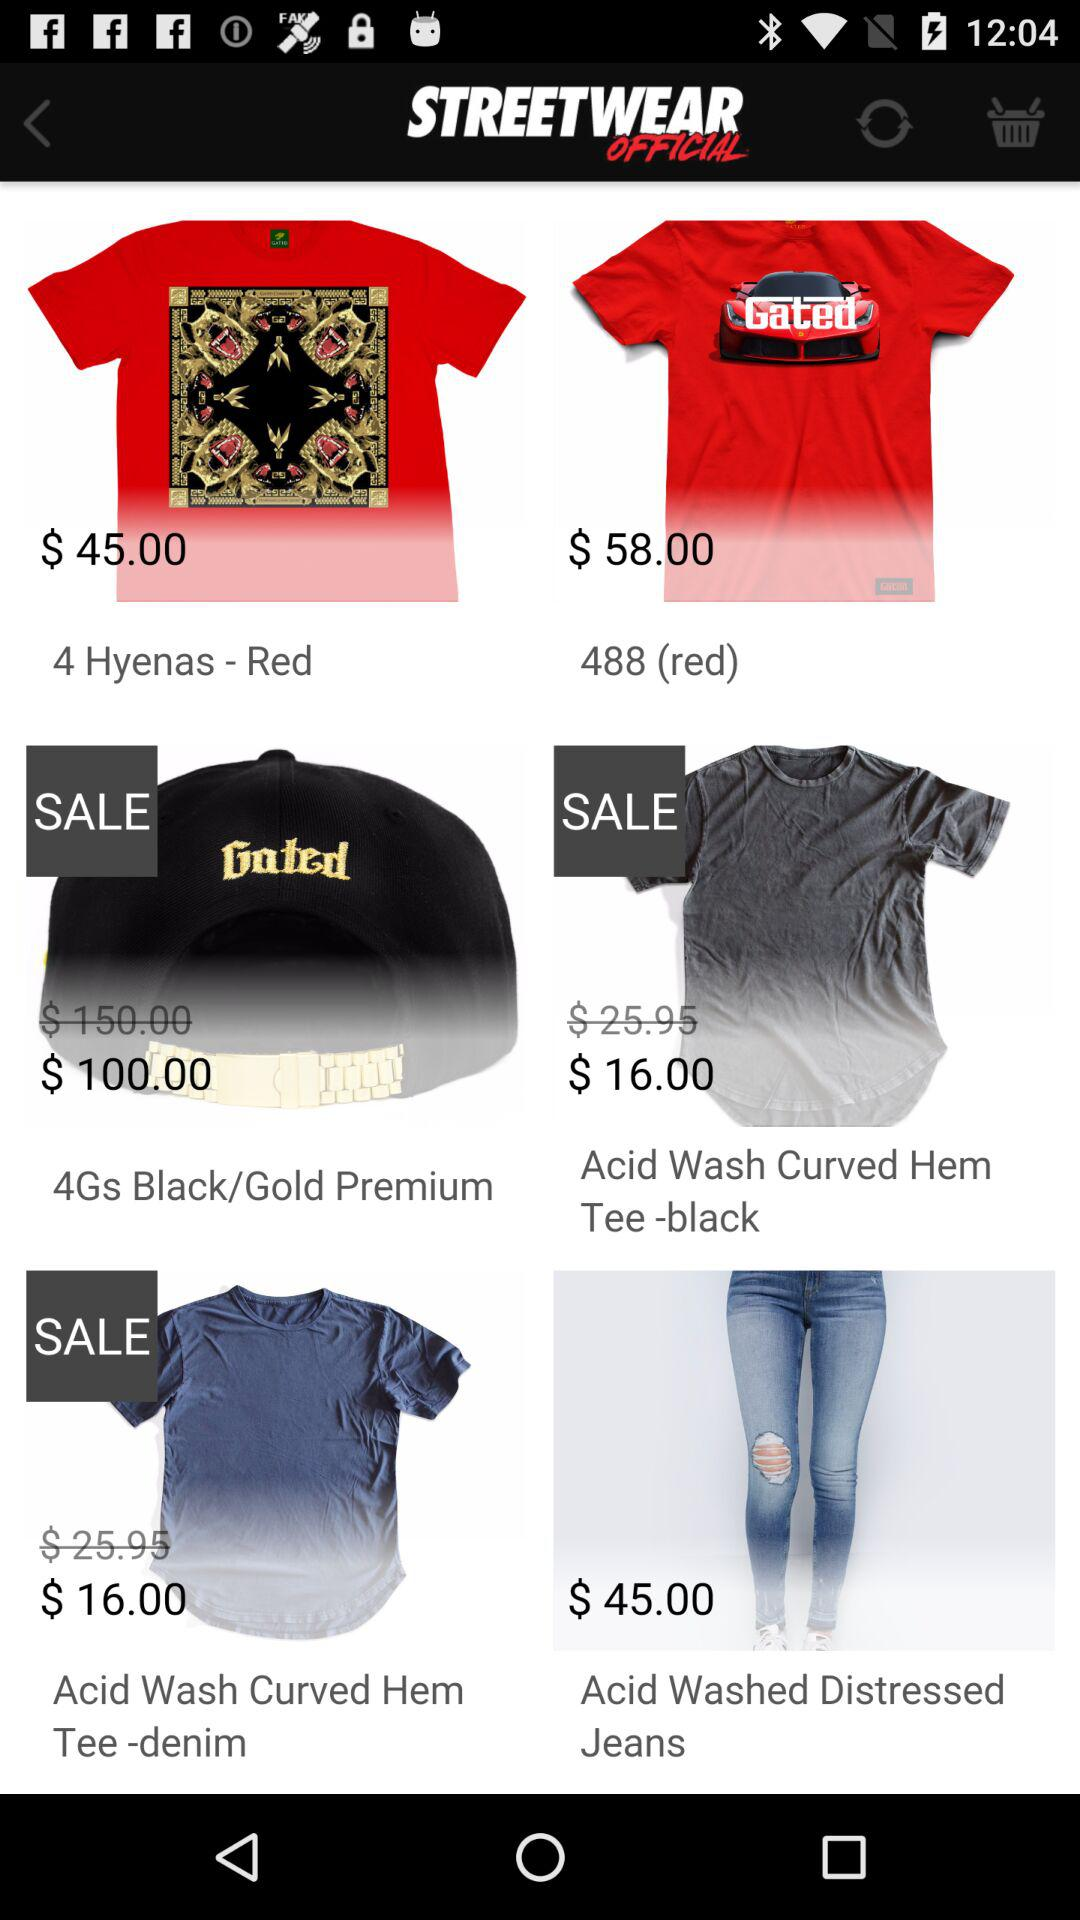What is the price of "4 Hyenas-Red"? The price of "4 Hyenas-Red" is $45.00. 